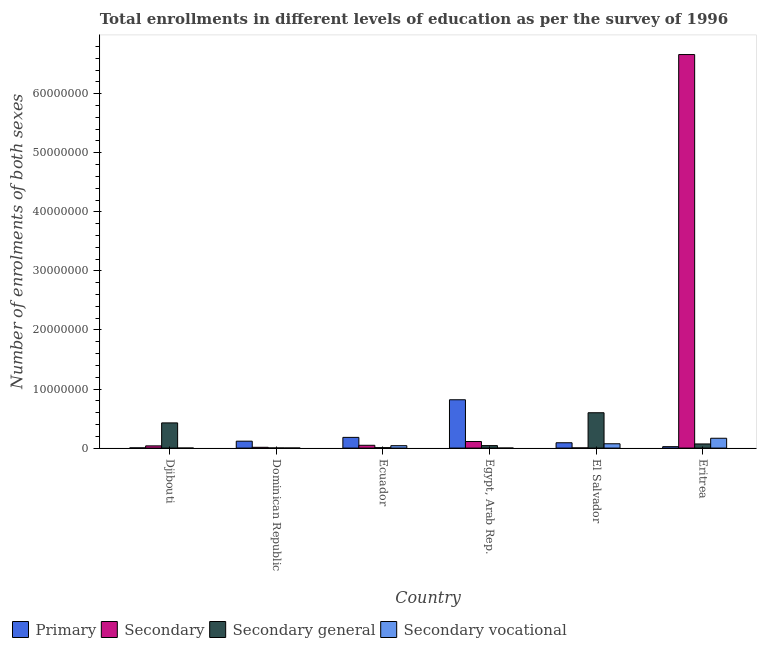How many different coloured bars are there?
Give a very brief answer. 4. Are the number of bars per tick equal to the number of legend labels?
Provide a short and direct response. Yes. How many bars are there on the 4th tick from the left?
Provide a short and direct response. 4. How many bars are there on the 6th tick from the right?
Provide a short and direct response. 4. What is the label of the 5th group of bars from the left?
Your answer should be compact. El Salvador. In how many cases, is the number of bars for a given country not equal to the number of legend labels?
Provide a succinct answer. 0. What is the number of enrolments in secondary education in Eritrea?
Your response must be concise. 6.66e+07. Across all countries, what is the maximum number of enrolments in secondary vocational education?
Offer a terse response. 1.67e+06. Across all countries, what is the minimum number of enrolments in secondary vocational education?
Ensure brevity in your answer.  4600. In which country was the number of enrolments in secondary general education maximum?
Your response must be concise. El Salvador. In which country was the number of enrolments in primary education minimum?
Provide a short and direct response. Djibouti. What is the total number of enrolments in secondary education in the graph?
Provide a short and direct response. 6.88e+07. What is the difference between the number of enrolments in secondary general education in Ecuador and that in El Salvador?
Ensure brevity in your answer.  -5.91e+06. What is the difference between the number of enrolments in secondary vocational education in Djibouti and the number of enrolments in primary education in Egypt, Arab Rep.?
Offer a very short reply. -8.18e+06. What is the average number of enrolments in secondary general education per country?
Ensure brevity in your answer.  1.91e+06. What is the difference between the number of enrolments in secondary vocational education and number of enrolments in primary education in Dominican Republic?
Your response must be concise. -1.16e+06. What is the ratio of the number of enrolments in secondary general education in Ecuador to that in Eritrea?
Keep it short and to the point. 0.1. Is the difference between the number of enrolments in secondary education in El Salvador and Eritrea greater than the difference between the number of enrolments in secondary vocational education in El Salvador and Eritrea?
Offer a terse response. No. What is the difference between the highest and the second highest number of enrolments in secondary education?
Ensure brevity in your answer.  6.55e+07. What is the difference between the highest and the lowest number of enrolments in secondary vocational education?
Provide a succinct answer. 1.66e+06. Is the sum of the number of enrolments in secondary vocational education in Ecuador and Egypt, Arab Rep. greater than the maximum number of enrolments in secondary education across all countries?
Offer a very short reply. No. What does the 2nd bar from the left in Egypt, Arab Rep. represents?
Offer a very short reply. Secondary. What does the 4th bar from the right in Egypt, Arab Rep. represents?
Offer a terse response. Primary. How many countries are there in the graph?
Offer a terse response. 6. What is the difference between two consecutive major ticks on the Y-axis?
Your answer should be compact. 1.00e+07. Are the values on the major ticks of Y-axis written in scientific E-notation?
Make the answer very short. No. Does the graph contain grids?
Your answer should be compact. No. How many legend labels are there?
Offer a very short reply. 4. What is the title of the graph?
Provide a succinct answer. Total enrollments in different levels of education as per the survey of 1996. What is the label or title of the Y-axis?
Ensure brevity in your answer.  Number of enrolments of both sexes. What is the Number of enrolments of both sexes in Primary in Djibouti?
Make the answer very short. 3.62e+04. What is the Number of enrolments of both sexes of Secondary in Djibouti?
Your answer should be compact. 3.76e+05. What is the Number of enrolments of both sexes in Secondary general in Djibouti?
Keep it short and to the point. 4.26e+06. What is the Number of enrolments of both sexes in Secondary vocational in Djibouti?
Offer a terse response. 4600. What is the Number of enrolments of both sexes of Primary in Dominican Republic?
Provide a succinct answer. 1.17e+06. What is the Number of enrolments of both sexes of Secondary in Dominican Republic?
Make the answer very short. 1.33e+05. What is the Number of enrolments of both sexes in Secondary general in Dominican Republic?
Ensure brevity in your answer.  2.15e+04. What is the Number of enrolments of both sexes in Secondary vocational in Dominican Republic?
Your answer should be very brief. 1.40e+04. What is the Number of enrolments of both sexes in Primary in Ecuador?
Make the answer very short. 1.81e+06. What is the Number of enrolments of both sexes of Secondary in Ecuador?
Make the answer very short. 4.74e+05. What is the Number of enrolments of both sexes in Secondary general in Ecuador?
Your answer should be very brief. 7.29e+04. What is the Number of enrolments of both sexes in Secondary vocational in Ecuador?
Give a very brief answer. 4.10e+05. What is the Number of enrolments of both sexes in Primary in Egypt, Arab Rep.?
Your answer should be compact. 8.19e+06. What is the Number of enrolments of both sexes of Secondary in Egypt, Arab Rep.?
Give a very brief answer. 1.11e+06. What is the Number of enrolments of both sexes in Secondary general in Egypt, Arab Rep.?
Give a very brief answer. 4.22e+05. What is the Number of enrolments of both sexes in Secondary vocational in Egypt, Arab Rep.?
Keep it short and to the point. 6059. What is the Number of enrolments of both sexes of Primary in El Salvador?
Give a very brief answer. 9.03e+05. What is the Number of enrolments of both sexes in Secondary in El Salvador?
Make the answer very short. 3.05e+04. What is the Number of enrolments of both sexes of Secondary general in El Salvador?
Provide a short and direct response. 5.99e+06. What is the Number of enrolments of both sexes in Secondary vocational in El Salvador?
Offer a very short reply. 7.31e+05. What is the Number of enrolments of both sexes of Primary in Eritrea?
Make the answer very short. 2.42e+05. What is the Number of enrolments of both sexes in Secondary in Eritrea?
Offer a terse response. 6.66e+07. What is the Number of enrolments of both sexes of Secondary general in Eritrea?
Keep it short and to the point. 7.01e+05. What is the Number of enrolments of both sexes in Secondary vocational in Eritrea?
Make the answer very short. 1.67e+06. Across all countries, what is the maximum Number of enrolments of both sexes in Primary?
Keep it short and to the point. 8.19e+06. Across all countries, what is the maximum Number of enrolments of both sexes in Secondary?
Offer a very short reply. 6.66e+07. Across all countries, what is the maximum Number of enrolments of both sexes in Secondary general?
Give a very brief answer. 5.99e+06. Across all countries, what is the maximum Number of enrolments of both sexes in Secondary vocational?
Offer a terse response. 1.67e+06. Across all countries, what is the minimum Number of enrolments of both sexes in Primary?
Offer a terse response. 3.62e+04. Across all countries, what is the minimum Number of enrolments of both sexes in Secondary?
Your answer should be very brief. 3.05e+04. Across all countries, what is the minimum Number of enrolments of both sexes in Secondary general?
Your response must be concise. 2.15e+04. Across all countries, what is the minimum Number of enrolments of both sexes of Secondary vocational?
Give a very brief answer. 4600. What is the total Number of enrolments of both sexes of Primary in the graph?
Provide a succinct answer. 1.23e+07. What is the total Number of enrolments of both sexes of Secondary in the graph?
Provide a short and direct response. 6.88e+07. What is the total Number of enrolments of both sexes in Secondary general in the graph?
Your answer should be very brief. 1.15e+07. What is the total Number of enrolments of both sexes in Secondary vocational in the graph?
Your answer should be compact. 2.83e+06. What is the difference between the Number of enrolments of both sexes of Primary in Djibouti and that in Dominican Republic?
Offer a very short reply. -1.14e+06. What is the difference between the Number of enrolments of both sexes of Secondary in Djibouti and that in Dominican Republic?
Provide a succinct answer. 2.43e+05. What is the difference between the Number of enrolments of both sexes of Secondary general in Djibouti and that in Dominican Republic?
Your response must be concise. 4.24e+06. What is the difference between the Number of enrolments of both sexes of Secondary vocational in Djibouti and that in Dominican Republic?
Provide a succinct answer. -9372. What is the difference between the Number of enrolments of both sexes in Primary in Djibouti and that in Ecuador?
Keep it short and to the point. -1.78e+06. What is the difference between the Number of enrolments of both sexes in Secondary in Djibouti and that in Ecuador?
Offer a very short reply. -9.83e+04. What is the difference between the Number of enrolments of both sexes in Secondary general in Djibouti and that in Ecuador?
Offer a terse response. 4.19e+06. What is the difference between the Number of enrolments of both sexes of Secondary vocational in Djibouti and that in Ecuador?
Your response must be concise. -4.05e+05. What is the difference between the Number of enrolments of both sexes in Primary in Djibouti and that in Egypt, Arab Rep.?
Keep it short and to the point. -8.15e+06. What is the difference between the Number of enrolments of both sexes in Secondary in Djibouti and that in Egypt, Arab Rep.?
Keep it short and to the point. -7.37e+05. What is the difference between the Number of enrolments of both sexes of Secondary general in Djibouti and that in Egypt, Arab Rep.?
Offer a terse response. 3.84e+06. What is the difference between the Number of enrolments of both sexes in Secondary vocational in Djibouti and that in Egypt, Arab Rep.?
Your answer should be compact. -1459. What is the difference between the Number of enrolments of both sexes in Primary in Djibouti and that in El Salvador?
Your answer should be compact. -8.66e+05. What is the difference between the Number of enrolments of both sexes of Secondary in Djibouti and that in El Salvador?
Your answer should be very brief. 3.45e+05. What is the difference between the Number of enrolments of both sexes in Secondary general in Djibouti and that in El Salvador?
Ensure brevity in your answer.  -1.72e+06. What is the difference between the Number of enrolments of both sexes in Secondary vocational in Djibouti and that in El Salvador?
Ensure brevity in your answer.  -7.26e+05. What is the difference between the Number of enrolments of both sexes of Primary in Djibouti and that in Eritrea?
Keep it short and to the point. -2.06e+05. What is the difference between the Number of enrolments of both sexes of Secondary in Djibouti and that in Eritrea?
Provide a short and direct response. -6.63e+07. What is the difference between the Number of enrolments of both sexes in Secondary general in Djibouti and that in Eritrea?
Ensure brevity in your answer.  3.56e+06. What is the difference between the Number of enrolments of both sexes of Secondary vocational in Djibouti and that in Eritrea?
Give a very brief answer. -1.66e+06. What is the difference between the Number of enrolments of both sexes in Primary in Dominican Republic and that in Ecuador?
Offer a terse response. -6.41e+05. What is the difference between the Number of enrolments of both sexes in Secondary in Dominican Republic and that in Ecuador?
Give a very brief answer. -3.41e+05. What is the difference between the Number of enrolments of both sexes of Secondary general in Dominican Republic and that in Ecuador?
Keep it short and to the point. -5.14e+04. What is the difference between the Number of enrolments of both sexes of Secondary vocational in Dominican Republic and that in Ecuador?
Give a very brief answer. -3.96e+05. What is the difference between the Number of enrolments of both sexes in Primary in Dominican Republic and that in Egypt, Arab Rep.?
Provide a succinct answer. -7.01e+06. What is the difference between the Number of enrolments of both sexes of Secondary in Dominican Republic and that in Egypt, Arab Rep.?
Your answer should be compact. -9.79e+05. What is the difference between the Number of enrolments of both sexes in Secondary general in Dominican Republic and that in Egypt, Arab Rep.?
Provide a succinct answer. -4.01e+05. What is the difference between the Number of enrolments of both sexes in Secondary vocational in Dominican Republic and that in Egypt, Arab Rep.?
Your answer should be compact. 7913. What is the difference between the Number of enrolments of both sexes of Primary in Dominican Republic and that in El Salvador?
Provide a succinct answer. 2.69e+05. What is the difference between the Number of enrolments of both sexes of Secondary in Dominican Republic and that in El Salvador?
Offer a terse response. 1.02e+05. What is the difference between the Number of enrolments of both sexes in Secondary general in Dominican Republic and that in El Salvador?
Your answer should be compact. -5.96e+06. What is the difference between the Number of enrolments of both sexes in Secondary vocational in Dominican Republic and that in El Salvador?
Your answer should be compact. -7.17e+05. What is the difference between the Number of enrolments of both sexes of Primary in Dominican Republic and that in Eritrea?
Ensure brevity in your answer.  9.30e+05. What is the difference between the Number of enrolments of both sexes of Secondary in Dominican Republic and that in Eritrea?
Offer a terse response. -6.65e+07. What is the difference between the Number of enrolments of both sexes in Secondary general in Dominican Republic and that in Eritrea?
Offer a terse response. -6.80e+05. What is the difference between the Number of enrolments of both sexes of Secondary vocational in Dominican Republic and that in Eritrea?
Offer a very short reply. -1.65e+06. What is the difference between the Number of enrolments of both sexes of Primary in Ecuador and that in Egypt, Arab Rep.?
Give a very brief answer. -6.37e+06. What is the difference between the Number of enrolments of both sexes in Secondary in Ecuador and that in Egypt, Arab Rep.?
Your answer should be very brief. -6.38e+05. What is the difference between the Number of enrolments of both sexes of Secondary general in Ecuador and that in Egypt, Arab Rep.?
Make the answer very short. -3.49e+05. What is the difference between the Number of enrolments of both sexes of Secondary vocational in Ecuador and that in Egypt, Arab Rep.?
Ensure brevity in your answer.  4.03e+05. What is the difference between the Number of enrolments of both sexes of Primary in Ecuador and that in El Salvador?
Offer a terse response. 9.10e+05. What is the difference between the Number of enrolments of both sexes in Secondary in Ecuador and that in El Salvador?
Provide a short and direct response. 4.43e+05. What is the difference between the Number of enrolments of both sexes of Secondary general in Ecuador and that in El Salvador?
Offer a very short reply. -5.91e+06. What is the difference between the Number of enrolments of both sexes of Secondary vocational in Ecuador and that in El Salvador?
Provide a succinct answer. -3.22e+05. What is the difference between the Number of enrolments of both sexes of Primary in Ecuador and that in Eritrea?
Provide a short and direct response. 1.57e+06. What is the difference between the Number of enrolments of both sexes in Secondary in Ecuador and that in Eritrea?
Provide a short and direct response. -6.62e+07. What is the difference between the Number of enrolments of both sexes in Secondary general in Ecuador and that in Eritrea?
Provide a succinct answer. -6.28e+05. What is the difference between the Number of enrolments of both sexes in Secondary vocational in Ecuador and that in Eritrea?
Offer a very short reply. -1.26e+06. What is the difference between the Number of enrolments of both sexes of Primary in Egypt, Arab Rep. and that in El Salvador?
Make the answer very short. 7.28e+06. What is the difference between the Number of enrolments of both sexes of Secondary in Egypt, Arab Rep. and that in El Salvador?
Offer a terse response. 1.08e+06. What is the difference between the Number of enrolments of both sexes of Secondary general in Egypt, Arab Rep. and that in El Salvador?
Provide a succinct answer. -5.56e+06. What is the difference between the Number of enrolments of both sexes in Secondary vocational in Egypt, Arab Rep. and that in El Salvador?
Offer a very short reply. -7.25e+05. What is the difference between the Number of enrolments of both sexes in Primary in Egypt, Arab Rep. and that in Eritrea?
Make the answer very short. 7.94e+06. What is the difference between the Number of enrolments of both sexes in Secondary in Egypt, Arab Rep. and that in Eritrea?
Offer a terse response. -6.55e+07. What is the difference between the Number of enrolments of both sexes of Secondary general in Egypt, Arab Rep. and that in Eritrea?
Ensure brevity in your answer.  -2.79e+05. What is the difference between the Number of enrolments of both sexes in Secondary vocational in Egypt, Arab Rep. and that in Eritrea?
Offer a very short reply. -1.66e+06. What is the difference between the Number of enrolments of both sexes in Primary in El Salvador and that in Eritrea?
Keep it short and to the point. 6.61e+05. What is the difference between the Number of enrolments of both sexes in Secondary in El Salvador and that in Eritrea?
Your response must be concise. -6.66e+07. What is the difference between the Number of enrolments of both sexes of Secondary general in El Salvador and that in Eritrea?
Your answer should be very brief. 5.28e+06. What is the difference between the Number of enrolments of both sexes of Secondary vocational in El Salvador and that in Eritrea?
Provide a short and direct response. -9.34e+05. What is the difference between the Number of enrolments of both sexes of Primary in Djibouti and the Number of enrolments of both sexes of Secondary in Dominican Republic?
Your answer should be very brief. -9.65e+04. What is the difference between the Number of enrolments of both sexes of Primary in Djibouti and the Number of enrolments of both sexes of Secondary general in Dominican Republic?
Your answer should be very brief. 1.47e+04. What is the difference between the Number of enrolments of both sexes of Primary in Djibouti and the Number of enrolments of both sexes of Secondary vocational in Dominican Republic?
Your response must be concise. 2.23e+04. What is the difference between the Number of enrolments of both sexes in Secondary in Djibouti and the Number of enrolments of both sexes in Secondary general in Dominican Republic?
Give a very brief answer. 3.54e+05. What is the difference between the Number of enrolments of both sexes of Secondary in Djibouti and the Number of enrolments of both sexes of Secondary vocational in Dominican Republic?
Your response must be concise. 3.62e+05. What is the difference between the Number of enrolments of both sexes of Secondary general in Djibouti and the Number of enrolments of both sexes of Secondary vocational in Dominican Republic?
Offer a very short reply. 4.25e+06. What is the difference between the Number of enrolments of both sexes of Primary in Djibouti and the Number of enrolments of both sexes of Secondary in Ecuador?
Your response must be concise. -4.38e+05. What is the difference between the Number of enrolments of both sexes in Primary in Djibouti and the Number of enrolments of both sexes in Secondary general in Ecuador?
Your answer should be very brief. -3.67e+04. What is the difference between the Number of enrolments of both sexes of Primary in Djibouti and the Number of enrolments of both sexes of Secondary vocational in Ecuador?
Provide a short and direct response. -3.73e+05. What is the difference between the Number of enrolments of both sexes in Secondary in Djibouti and the Number of enrolments of both sexes in Secondary general in Ecuador?
Ensure brevity in your answer.  3.03e+05. What is the difference between the Number of enrolments of both sexes in Secondary in Djibouti and the Number of enrolments of both sexes in Secondary vocational in Ecuador?
Keep it short and to the point. -3.40e+04. What is the difference between the Number of enrolments of both sexes in Secondary general in Djibouti and the Number of enrolments of both sexes in Secondary vocational in Ecuador?
Make the answer very short. 3.85e+06. What is the difference between the Number of enrolments of both sexes in Primary in Djibouti and the Number of enrolments of both sexes in Secondary in Egypt, Arab Rep.?
Provide a short and direct response. -1.08e+06. What is the difference between the Number of enrolments of both sexes of Primary in Djibouti and the Number of enrolments of both sexes of Secondary general in Egypt, Arab Rep.?
Your answer should be compact. -3.86e+05. What is the difference between the Number of enrolments of both sexes in Primary in Djibouti and the Number of enrolments of both sexes in Secondary vocational in Egypt, Arab Rep.?
Your answer should be compact. 3.02e+04. What is the difference between the Number of enrolments of both sexes in Secondary in Djibouti and the Number of enrolments of both sexes in Secondary general in Egypt, Arab Rep.?
Your answer should be compact. -4.69e+04. What is the difference between the Number of enrolments of both sexes in Secondary in Djibouti and the Number of enrolments of both sexes in Secondary vocational in Egypt, Arab Rep.?
Provide a succinct answer. 3.69e+05. What is the difference between the Number of enrolments of both sexes of Secondary general in Djibouti and the Number of enrolments of both sexes of Secondary vocational in Egypt, Arab Rep.?
Give a very brief answer. 4.26e+06. What is the difference between the Number of enrolments of both sexes of Primary in Djibouti and the Number of enrolments of both sexes of Secondary in El Salvador?
Provide a succinct answer. 5760. What is the difference between the Number of enrolments of both sexes of Primary in Djibouti and the Number of enrolments of both sexes of Secondary general in El Salvador?
Ensure brevity in your answer.  -5.95e+06. What is the difference between the Number of enrolments of both sexes of Primary in Djibouti and the Number of enrolments of both sexes of Secondary vocational in El Salvador?
Ensure brevity in your answer.  -6.95e+05. What is the difference between the Number of enrolments of both sexes of Secondary in Djibouti and the Number of enrolments of both sexes of Secondary general in El Salvador?
Your response must be concise. -5.61e+06. What is the difference between the Number of enrolments of both sexes of Secondary in Djibouti and the Number of enrolments of both sexes of Secondary vocational in El Salvador?
Offer a terse response. -3.55e+05. What is the difference between the Number of enrolments of both sexes in Secondary general in Djibouti and the Number of enrolments of both sexes in Secondary vocational in El Salvador?
Keep it short and to the point. 3.53e+06. What is the difference between the Number of enrolments of both sexes of Primary in Djibouti and the Number of enrolments of both sexes of Secondary in Eritrea?
Keep it short and to the point. -6.66e+07. What is the difference between the Number of enrolments of both sexes in Primary in Djibouti and the Number of enrolments of both sexes in Secondary general in Eritrea?
Offer a terse response. -6.65e+05. What is the difference between the Number of enrolments of both sexes of Primary in Djibouti and the Number of enrolments of both sexes of Secondary vocational in Eritrea?
Give a very brief answer. -1.63e+06. What is the difference between the Number of enrolments of both sexes in Secondary in Djibouti and the Number of enrolments of both sexes in Secondary general in Eritrea?
Offer a terse response. -3.26e+05. What is the difference between the Number of enrolments of both sexes of Secondary in Djibouti and the Number of enrolments of both sexes of Secondary vocational in Eritrea?
Provide a succinct answer. -1.29e+06. What is the difference between the Number of enrolments of both sexes in Secondary general in Djibouti and the Number of enrolments of both sexes in Secondary vocational in Eritrea?
Make the answer very short. 2.60e+06. What is the difference between the Number of enrolments of both sexes in Primary in Dominican Republic and the Number of enrolments of both sexes in Secondary in Ecuador?
Your response must be concise. 6.98e+05. What is the difference between the Number of enrolments of both sexes in Primary in Dominican Republic and the Number of enrolments of both sexes in Secondary general in Ecuador?
Give a very brief answer. 1.10e+06. What is the difference between the Number of enrolments of both sexes of Primary in Dominican Republic and the Number of enrolments of both sexes of Secondary vocational in Ecuador?
Provide a succinct answer. 7.62e+05. What is the difference between the Number of enrolments of both sexes of Secondary in Dominican Republic and the Number of enrolments of both sexes of Secondary general in Ecuador?
Keep it short and to the point. 5.98e+04. What is the difference between the Number of enrolments of both sexes in Secondary in Dominican Republic and the Number of enrolments of both sexes in Secondary vocational in Ecuador?
Make the answer very short. -2.77e+05. What is the difference between the Number of enrolments of both sexes of Secondary general in Dominican Republic and the Number of enrolments of both sexes of Secondary vocational in Ecuador?
Your answer should be very brief. -3.88e+05. What is the difference between the Number of enrolments of both sexes of Primary in Dominican Republic and the Number of enrolments of both sexes of Secondary in Egypt, Arab Rep.?
Keep it short and to the point. 5.94e+04. What is the difference between the Number of enrolments of both sexes in Primary in Dominican Republic and the Number of enrolments of both sexes in Secondary general in Egypt, Arab Rep.?
Give a very brief answer. 7.49e+05. What is the difference between the Number of enrolments of both sexes in Primary in Dominican Republic and the Number of enrolments of both sexes in Secondary vocational in Egypt, Arab Rep.?
Provide a short and direct response. 1.17e+06. What is the difference between the Number of enrolments of both sexes in Secondary in Dominican Republic and the Number of enrolments of both sexes in Secondary general in Egypt, Arab Rep.?
Your answer should be compact. -2.90e+05. What is the difference between the Number of enrolments of both sexes of Secondary in Dominican Republic and the Number of enrolments of both sexes of Secondary vocational in Egypt, Arab Rep.?
Your answer should be compact. 1.27e+05. What is the difference between the Number of enrolments of both sexes of Secondary general in Dominican Republic and the Number of enrolments of both sexes of Secondary vocational in Egypt, Arab Rep.?
Your answer should be compact. 1.54e+04. What is the difference between the Number of enrolments of both sexes in Primary in Dominican Republic and the Number of enrolments of both sexes in Secondary in El Salvador?
Your response must be concise. 1.14e+06. What is the difference between the Number of enrolments of both sexes in Primary in Dominican Republic and the Number of enrolments of both sexes in Secondary general in El Salvador?
Ensure brevity in your answer.  -4.81e+06. What is the difference between the Number of enrolments of both sexes in Primary in Dominican Republic and the Number of enrolments of both sexes in Secondary vocational in El Salvador?
Offer a terse response. 4.41e+05. What is the difference between the Number of enrolments of both sexes of Secondary in Dominican Republic and the Number of enrolments of both sexes of Secondary general in El Salvador?
Your answer should be very brief. -5.85e+06. What is the difference between the Number of enrolments of both sexes of Secondary in Dominican Republic and the Number of enrolments of both sexes of Secondary vocational in El Salvador?
Your answer should be very brief. -5.98e+05. What is the difference between the Number of enrolments of both sexes in Secondary general in Dominican Republic and the Number of enrolments of both sexes in Secondary vocational in El Salvador?
Your response must be concise. -7.10e+05. What is the difference between the Number of enrolments of both sexes in Primary in Dominican Republic and the Number of enrolments of both sexes in Secondary in Eritrea?
Keep it short and to the point. -6.55e+07. What is the difference between the Number of enrolments of both sexes of Primary in Dominican Republic and the Number of enrolments of both sexes of Secondary general in Eritrea?
Offer a very short reply. 4.70e+05. What is the difference between the Number of enrolments of both sexes in Primary in Dominican Republic and the Number of enrolments of both sexes in Secondary vocational in Eritrea?
Offer a very short reply. -4.94e+05. What is the difference between the Number of enrolments of both sexes in Secondary in Dominican Republic and the Number of enrolments of both sexes in Secondary general in Eritrea?
Your answer should be compact. -5.69e+05. What is the difference between the Number of enrolments of both sexes of Secondary in Dominican Republic and the Number of enrolments of both sexes of Secondary vocational in Eritrea?
Ensure brevity in your answer.  -1.53e+06. What is the difference between the Number of enrolments of both sexes of Secondary general in Dominican Republic and the Number of enrolments of both sexes of Secondary vocational in Eritrea?
Keep it short and to the point. -1.64e+06. What is the difference between the Number of enrolments of both sexes of Primary in Ecuador and the Number of enrolments of both sexes of Secondary in Egypt, Arab Rep.?
Offer a terse response. 7.00e+05. What is the difference between the Number of enrolments of both sexes of Primary in Ecuador and the Number of enrolments of both sexes of Secondary general in Egypt, Arab Rep.?
Give a very brief answer. 1.39e+06. What is the difference between the Number of enrolments of both sexes in Primary in Ecuador and the Number of enrolments of both sexes in Secondary vocational in Egypt, Arab Rep.?
Your response must be concise. 1.81e+06. What is the difference between the Number of enrolments of both sexes in Secondary in Ecuador and the Number of enrolments of both sexes in Secondary general in Egypt, Arab Rep.?
Your answer should be compact. 5.14e+04. What is the difference between the Number of enrolments of both sexes of Secondary in Ecuador and the Number of enrolments of both sexes of Secondary vocational in Egypt, Arab Rep.?
Your answer should be compact. 4.68e+05. What is the difference between the Number of enrolments of both sexes of Secondary general in Ecuador and the Number of enrolments of both sexes of Secondary vocational in Egypt, Arab Rep.?
Give a very brief answer. 6.68e+04. What is the difference between the Number of enrolments of both sexes in Primary in Ecuador and the Number of enrolments of both sexes in Secondary in El Salvador?
Your answer should be compact. 1.78e+06. What is the difference between the Number of enrolments of both sexes of Primary in Ecuador and the Number of enrolments of both sexes of Secondary general in El Salvador?
Provide a succinct answer. -4.17e+06. What is the difference between the Number of enrolments of both sexes of Primary in Ecuador and the Number of enrolments of both sexes of Secondary vocational in El Salvador?
Your answer should be very brief. 1.08e+06. What is the difference between the Number of enrolments of both sexes in Secondary in Ecuador and the Number of enrolments of both sexes in Secondary general in El Salvador?
Give a very brief answer. -5.51e+06. What is the difference between the Number of enrolments of both sexes in Secondary in Ecuador and the Number of enrolments of both sexes in Secondary vocational in El Salvador?
Offer a very short reply. -2.57e+05. What is the difference between the Number of enrolments of both sexes of Secondary general in Ecuador and the Number of enrolments of both sexes of Secondary vocational in El Salvador?
Your answer should be compact. -6.58e+05. What is the difference between the Number of enrolments of both sexes of Primary in Ecuador and the Number of enrolments of both sexes of Secondary in Eritrea?
Make the answer very short. -6.48e+07. What is the difference between the Number of enrolments of both sexes of Primary in Ecuador and the Number of enrolments of both sexes of Secondary general in Eritrea?
Your answer should be compact. 1.11e+06. What is the difference between the Number of enrolments of both sexes of Primary in Ecuador and the Number of enrolments of both sexes of Secondary vocational in Eritrea?
Give a very brief answer. 1.47e+05. What is the difference between the Number of enrolments of both sexes in Secondary in Ecuador and the Number of enrolments of both sexes in Secondary general in Eritrea?
Your answer should be compact. -2.27e+05. What is the difference between the Number of enrolments of both sexes of Secondary in Ecuador and the Number of enrolments of both sexes of Secondary vocational in Eritrea?
Ensure brevity in your answer.  -1.19e+06. What is the difference between the Number of enrolments of both sexes in Secondary general in Ecuador and the Number of enrolments of both sexes in Secondary vocational in Eritrea?
Ensure brevity in your answer.  -1.59e+06. What is the difference between the Number of enrolments of both sexes of Primary in Egypt, Arab Rep. and the Number of enrolments of both sexes of Secondary in El Salvador?
Provide a succinct answer. 8.15e+06. What is the difference between the Number of enrolments of both sexes in Primary in Egypt, Arab Rep. and the Number of enrolments of both sexes in Secondary general in El Salvador?
Your response must be concise. 2.20e+06. What is the difference between the Number of enrolments of both sexes in Primary in Egypt, Arab Rep. and the Number of enrolments of both sexes in Secondary vocational in El Salvador?
Make the answer very short. 7.45e+06. What is the difference between the Number of enrolments of both sexes of Secondary in Egypt, Arab Rep. and the Number of enrolments of both sexes of Secondary general in El Salvador?
Provide a succinct answer. -4.87e+06. What is the difference between the Number of enrolments of both sexes in Secondary in Egypt, Arab Rep. and the Number of enrolments of both sexes in Secondary vocational in El Salvador?
Keep it short and to the point. 3.81e+05. What is the difference between the Number of enrolments of both sexes in Secondary general in Egypt, Arab Rep. and the Number of enrolments of both sexes in Secondary vocational in El Salvador?
Your answer should be compact. -3.09e+05. What is the difference between the Number of enrolments of both sexes of Primary in Egypt, Arab Rep. and the Number of enrolments of both sexes of Secondary in Eritrea?
Offer a terse response. -5.84e+07. What is the difference between the Number of enrolments of both sexes of Primary in Egypt, Arab Rep. and the Number of enrolments of both sexes of Secondary general in Eritrea?
Give a very brief answer. 7.48e+06. What is the difference between the Number of enrolments of both sexes of Primary in Egypt, Arab Rep. and the Number of enrolments of both sexes of Secondary vocational in Eritrea?
Your response must be concise. 6.52e+06. What is the difference between the Number of enrolments of both sexes of Secondary in Egypt, Arab Rep. and the Number of enrolments of both sexes of Secondary general in Eritrea?
Provide a short and direct response. 4.11e+05. What is the difference between the Number of enrolments of both sexes in Secondary in Egypt, Arab Rep. and the Number of enrolments of both sexes in Secondary vocational in Eritrea?
Offer a very short reply. -5.53e+05. What is the difference between the Number of enrolments of both sexes in Secondary general in Egypt, Arab Rep. and the Number of enrolments of both sexes in Secondary vocational in Eritrea?
Provide a short and direct response. -1.24e+06. What is the difference between the Number of enrolments of both sexes in Primary in El Salvador and the Number of enrolments of both sexes in Secondary in Eritrea?
Keep it short and to the point. -6.57e+07. What is the difference between the Number of enrolments of both sexes of Primary in El Salvador and the Number of enrolments of both sexes of Secondary general in Eritrea?
Offer a very short reply. 2.01e+05. What is the difference between the Number of enrolments of both sexes of Primary in El Salvador and the Number of enrolments of both sexes of Secondary vocational in Eritrea?
Make the answer very short. -7.63e+05. What is the difference between the Number of enrolments of both sexes in Secondary in El Salvador and the Number of enrolments of both sexes in Secondary general in Eritrea?
Offer a terse response. -6.71e+05. What is the difference between the Number of enrolments of both sexes in Secondary in El Salvador and the Number of enrolments of both sexes in Secondary vocational in Eritrea?
Make the answer very short. -1.63e+06. What is the difference between the Number of enrolments of both sexes in Secondary general in El Salvador and the Number of enrolments of both sexes in Secondary vocational in Eritrea?
Your response must be concise. 4.32e+06. What is the average Number of enrolments of both sexes in Primary per country?
Provide a short and direct response. 2.06e+06. What is the average Number of enrolments of both sexes of Secondary per country?
Your response must be concise. 1.15e+07. What is the average Number of enrolments of both sexes of Secondary general per country?
Give a very brief answer. 1.91e+06. What is the average Number of enrolments of both sexes of Secondary vocational per country?
Keep it short and to the point. 4.72e+05. What is the difference between the Number of enrolments of both sexes in Primary and Number of enrolments of both sexes in Secondary in Djibouti?
Your response must be concise. -3.39e+05. What is the difference between the Number of enrolments of both sexes in Primary and Number of enrolments of both sexes in Secondary general in Djibouti?
Make the answer very short. -4.23e+06. What is the difference between the Number of enrolments of both sexes in Primary and Number of enrolments of both sexes in Secondary vocational in Djibouti?
Provide a short and direct response. 3.16e+04. What is the difference between the Number of enrolments of both sexes of Secondary and Number of enrolments of both sexes of Secondary general in Djibouti?
Ensure brevity in your answer.  -3.89e+06. What is the difference between the Number of enrolments of both sexes of Secondary and Number of enrolments of both sexes of Secondary vocational in Djibouti?
Make the answer very short. 3.71e+05. What is the difference between the Number of enrolments of both sexes of Secondary general and Number of enrolments of both sexes of Secondary vocational in Djibouti?
Offer a terse response. 4.26e+06. What is the difference between the Number of enrolments of both sexes of Primary and Number of enrolments of both sexes of Secondary in Dominican Republic?
Offer a very short reply. 1.04e+06. What is the difference between the Number of enrolments of both sexes in Primary and Number of enrolments of both sexes in Secondary general in Dominican Republic?
Ensure brevity in your answer.  1.15e+06. What is the difference between the Number of enrolments of both sexes in Primary and Number of enrolments of both sexes in Secondary vocational in Dominican Republic?
Your answer should be very brief. 1.16e+06. What is the difference between the Number of enrolments of both sexes of Secondary and Number of enrolments of both sexes of Secondary general in Dominican Republic?
Offer a very short reply. 1.11e+05. What is the difference between the Number of enrolments of both sexes in Secondary and Number of enrolments of both sexes in Secondary vocational in Dominican Republic?
Give a very brief answer. 1.19e+05. What is the difference between the Number of enrolments of both sexes of Secondary general and Number of enrolments of both sexes of Secondary vocational in Dominican Republic?
Make the answer very short. 7528. What is the difference between the Number of enrolments of both sexes of Primary and Number of enrolments of both sexes of Secondary in Ecuador?
Offer a very short reply. 1.34e+06. What is the difference between the Number of enrolments of both sexes of Primary and Number of enrolments of both sexes of Secondary general in Ecuador?
Provide a succinct answer. 1.74e+06. What is the difference between the Number of enrolments of both sexes in Primary and Number of enrolments of both sexes in Secondary vocational in Ecuador?
Offer a terse response. 1.40e+06. What is the difference between the Number of enrolments of both sexes of Secondary and Number of enrolments of both sexes of Secondary general in Ecuador?
Make the answer very short. 4.01e+05. What is the difference between the Number of enrolments of both sexes of Secondary and Number of enrolments of both sexes of Secondary vocational in Ecuador?
Provide a succinct answer. 6.43e+04. What is the difference between the Number of enrolments of both sexes in Secondary general and Number of enrolments of both sexes in Secondary vocational in Ecuador?
Ensure brevity in your answer.  -3.37e+05. What is the difference between the Number of enrolments of both sexes of Primary and Number of enrolments of both sexes of Secondary in Egypt, Arab Rep.?
Your response must be concise. 7.07e+06. What is the difference between the Number of enrolments of both sexes of Primary and Number of enrolments of both sexes of Secondary general in Egypt, Arab Rep.?
Offer a terse response. 7.76e+06. What is the difference between the Number of enrolments of both sexes in Primary and Number of enrolments of both sexes in Secondary vocational in Egypt, Arab Rep.?
Provide a succinct answer. 8.18e+06. What is the difference between the Number of enrolments of both sexes in Secondary and Number of enrolments of both sexes in Secondary general in Egypt, Arab Rep.?
Your response must be concise. 6.90e+05. What is the difference between the Number of enrolments of both sexes in Secondary and Number of enrolments of both sexes in Secondary vocational in Egypt, Arab Rep.?
Your answer should be compact. 1.11e+06. What is the difference between the Number of enrolments of both sexes in Secondary general and Number of enrolments of both sexes in Secondary vocational in Egypt, Arab Rep.?
Give a very brief answer. 4.16e+05. What is the difference between the Number of enrolments of both sexes of Primary and Number of enrolments of both sexes of Secondary in El Salvador?
Ensure brevity in your answer.  8.72e+05. What is the difference between the Number of enrolments of both sexes in Primary and Number of enrolments of both sexes in Secondary general in El Salvador?
Offer a terse response. -5.08e+06. What is the difference between the Number of enrolments of both sexes in Primary and Number of enrolments of both sexes in Secondary vocational in El Salvador?
Offer a very short reply. 1.72e+05. What is the difference between the Number of enrolments of both sexes of Secondary and Number of enrolments of both sexes of Secondary general in El Salvador?
Provide a succinct answer. -5.96e+06. What is the difference between the Number of enrolments of both sexes of Secondary and Number of enrolments of both sexes of Secondary vocational in El Salvador?
Provide a short and direct response. -7.01e+05. What is the difference between the Number of enrolments of both sexes in Secondary general and Number of enrolments of both sexes in Secondary vocational in El Salvador?
Your answer should be very brief. 5.26e+06. What is the difference between the Number of enrolments of both sexes of Primary and Number of enrolments of both sexes of Secondary in Eritrea?
Ensure brevity in your answer.  -6.64e+07. What is the difference between the Number of enrolments of both sexes in Primary and Number of enrolments of both sexes in Secondary general in Eritrea?
Offer a terse response. -4.60e+05. What is the difference between the Number of enrolments of both sexes in Primary and Number of enrolments of both sexes in Secondary vocational in Eritrea?
Provide a short and direct response. -1.42e+06. What is the difference between the Number of enrolments of both sexes in Secondary and Number of enrolments of both sexes in Secondary general in Eritrea?
Ensure brevity in your answer.  6.59e+07. What is the difference between the Number of enrolments of both sexes of Secondary and Number of enrolments of both sexes of Secondary vocational in Eritrea?
Your response must be concise. 6.50e+07. What is the difference between the Number of enrolments of both sexes of Secondary general and Number of enrolments of both sexes of Secondary vocational in Eritrea?
Provide a succinct answer. -9.64e+05. What is the ratio of the Number of enrolments of both sexes of Primary in Djibouti to that in Dominican Republic?
Provide a short and direct response. 0.03. What is the ratio of the Number of enrolments of both sexes of Secondary in Djibouti to that in Dominican Republic?
Provide a succinct answer. 2.83. What is the ratio of the Number of enrolments of both sexes of Secondary general in Djibouti to that in Dominican Republic?
Make the answer very short. 198.34. What is the ratio of the Number of enrolments of both sexes in Secondary vocational in Djibouti to that in Dominican Republic?
Offer a very short reply. 0.33. What is the ratio of the Number of enrolments of both sexes of Primary in Djibouti to that in Ecuador?
Keep it short and to the point. 0.02. What is the ratio of the Number of enrolments of both sexes in Secondary in Djibouti to that in Ecuador?
Offer a very short reply. 0.79. What is the ratio of the Number of enrolments of both sexes in Secondary general in Djibouti to that in Ecuador?
Your answer should be very brief. 58.51. What is the ratio of the Number of enrolments of both sexes in Secondary vocational in Djibouti to that in Ecuador?
Offer a terse response. 0.01. What is the ratio of the Number of enrolments of both sexes of Primary in Djibouti to that in Egypt, Arab Rep.?
Your answer should be compact. 0. What is the ratio of the Number of enrolments of both sexes of Secondary in Djibouti to that in Egypt, Arab Rep.?
Offer a terse response. 0.34. What is the ratio of the Number of enrolments of both sexes in Secondary general in Djibouti to that in Egypt, Arab Rep.?
Provide a short and direct response. 10.1. What is the ratio of the Number of enrolments of both sexes in Secondary vocational in Djibouti to that in Egypt, Arab Rep.?
Your answer should be very brief. 0.76. What is the ratio of the Number of enrolments of both sexes of Primary in Djibouti to that in El Salvador?
Offer a very short reply. 0.04. What is the ratio of the Number of enrolments of both sexes of Secondary in Djibouti to that in El Salvador?
Keep it short and to the point. 12.33. What is the ratio of the Number of enrolments of both sexes of Secondary general in Djibouti to that in El Salvador?
Make the answer very short. 0.71. What is the ratio of the Number of enrolments of both sexes in Secondary vocational in Djibouti to that in El Salvador?
Provide a succinct answer. 0.01. What is the ratio of the Number of enrolments of both sexes of Primary in Djibouti to that in Eritrea?
Offer a terse response. 0.15. What is the ratio of the Number of enrolments of both sexes in Secondary in Djibouti to that in Eritrea?
Keep it short and to the point. 0.01. What is the ratio of the Number of enrolments of both sexes in Secondary general in Djibouti to that in Eritrea?
Provide a succinct answer. 6.08. What is the ratio of the Number of enrolments of both sexes of Secondary vocational in Djibouti to that in Eritrea?
Give a very brief answer. 0. What is the ratio of the Number of enrolments of both sexes of Primary in Dominican Republic to that in Ecuador?
Keep it short and to the point. 0.65. What is the ratio of the Number of enrolments of both sexes of Secondary in Dominican Republic to that in Ecuador?
Your response must be concise. 0.28. What is the ratio of the Number of enrolments of both sexes in Secondary general in Dominican Republic to that in Ecuador?
Give a very brief answer. 0.29. What is the ratio of the Number of enrolments of both sexes of Secondary vocational in Dominican Republic to that in Ecuador?
Your answer should be compact. 0.03. What is the ratio of the Number of enrolments of both sexes in Primary in Dominican Republic to that in Egypt, Arab Rep.?
Give a very brief answer. 0.14. What is the ratio of the Number of enrolments of both sexes in Secondary in Dominican Republic to that in Egypt, Arab Rep.?
Provide a succinct answer. 0.12. What is the ratio of the Number of enrolments of both sexes of Secondary general in Dominican Republic to that in Egypt, Arab Rep.?
Your response must be concise. 0.05. What is the ratio of the Number of enrolments of both sexes of Secondary vocational in Dominican Republic to that in Egypt, Arab Rep.?
Your answer should be compact. 2.31. What is the ratio of the Number of enrolments of both sexes of Primary in Dominican Republic to that in El Salvador?
Make the answer very short. 1.3. What is the ratio of the Number of enrolments of both sexes in Secondary in Dominican Republic to that in El Salvador?
Your answer should be compact. 4.36. What is the ratio of the Number of enrolments of both sexes in Secondary general in Dominican Republic to that in El Salvador?
Give a very brief answer. 0. What is the ratio of the Number of enrolments of both sexes of Secondary vocational in Dominican Republic to that in El Salvador?
Provide a short and direct response. 0.02. What is the ratio of the Number of enrolments of both sexes of Primary in Dominican Republic to that in Eritrea?
Provide a short and direct response. 4.85. What is the ratio of the Number of enrolments of both sexes in Secondary in Dominican Republic to that in Eritrea?
Ensure brevity in your answer.  0. What is the ratio of the Number of enrolments of both sexes of Secondary general in Dominican Republic to that in Eritrea?
Keep it short and to the point. 0.03. What is the ratio of the Number of enrolments of both sexes in Secondary vocational in Dominican Republic to that in Eritrea?
Ensure brevity in your answer.  0.01. What is the ratio of the Number of enrolments of both sexes of Primary in Ecuador to that in Egypt, Arab Rep.?
Your response must be concise. 0.22. What is the ratio of the Number of enrolments of both sexes in Secondary in Ecuador to that in Egypt, Arab Rep.?
Offer a very short reply. 0.43. What is the ratio of the Number of enrolments of both sexes in Secondary general in Ecuador to that in Egypt, Arab Rep.?
Offer a very short reply. 0.17. What is the ratio of the Number of enrolments of both sexes of Secondary vocational in Ecuador to that in Egypt, Arab Rep.?
Provide a succinct answer. 67.59. What is the ratio of the Number of enrolments of both sexes of Primary in Ecuador to that in El Salvador?
Your answer should be compact. 2.01. What is the ratio of the Number of enrolments of both sexes in Secondary in Ecuador to that in El Salvador?
Give a very brief answer. 15.55. What is the ratio of the Number of enrolments of both sexes of Secondary general in Ecuador to that in El Salvador?
Offer a terse response. 0.01. What is the ratio of the Number of enrolments of both sexes in Secondary vocational in Ecuador to that in El Salvador?
Keep it short and to the point. 0.56. What is the ratio of the Number of enrolments of both sexes in Primary in Ecuador to that in Eritrea?
Offer a very short reply. 7.5. What is the ratio of the Number of enrolments of both sexes in Secondary in Ecuador to that in Eritrea?
Keep it short and to the point. 0.01. What is the ratio of the Number of enrolments of both sexes of Secondary general in Ecuador to that in Eritrea?
Ensure brevity in your answer.  0.1. What is the ratio of the Number of enrolments of both sexes in Secondary vocational in Ecuador to that in Eritrea?
Give a very brief answer. 0.25. What is the ratio of the Number of enrolments of both sexes in Primary in Egypt, Arab Rep. to that in El Salvador?
Your answer should be compact. 9.07. What is the ratio of the Number of enrolments of both sexes in Secondary in Egypt, Arab Rep. to that in El Salvador?
Your answer should be compact. 36.51. What is the ratio of the Number of enrolments of both sexes in Secondary general in Egypt, Arab Rep. to that in El Salvador?
Your answer should be compact. 0.07. What is the ratio of the Number of enrolments of both sexes of Secondary vocational in Egypt, Arab Rep. to that in El Salvador?
Offer a very short reply. 0.01. What is the ratio of the Number of enrolments of both sexes of Primary in Egypt, Arab Rep. to that in Eritrea?
Offer a terse response. 33.86. What is the ratio of the Number of enrolments of both sexes of Secondary in Egypt, Arab Rep. to that in Eritrea?
Give a very brief answer. 0.02. What is the ratio of the Number of enrolments of both sexes of Secondary general in Egypt, Arab Rep. to that in Eritrea?
Keep it short and to the point. 0.6. What is the ratio of the Number of enrolments of both sexes in Secondary vocational in Egypt, Arab Rep. to that in Eritrea?
Offer a very short reply. 0. What is the ratio of the Number of enrolments of both sexes of Primary in El Salvador to that in Eritrea?
Ensure brevity in your answer.  3.73. What is the ratio of the Number of enrolments of both sexes of Secondary general in El Salvador to that in Eritrea?
Your answer should be very brief. 8.54. What is the ratio of the Number of enrolments of both sexes of Secondary vocational in El Salvador to that in Eritrea?
Keep it short and to the point. 0.44. What is the difference between the highest and the second highest Number of enrolments of both sexes of Primary?
Offer a terse response. 6.37e+06. What is the difference between the highest and the second highest Number of enrolments of both sexes in Secondary?
Offer a very short reply. 6.55e+07. What is the difference between the highest and the second highest Number of enrolments of both sexes in Secondary general?
Your answer should be compact. 1.72e+06. What is the difference between the highest and the second highest Number of enrolments of both sexes of Secondary vocational?
Give a very brief answer. 9.34e+05. What is the difference between the highest and the lowest Number of enrolments of both sexes of Primary?
Provide a short and direct response. 8.15e+06. What is the difference between the highest and the lowest Number of enrolments of both sexes in Secondary?
Your answer should be very brief. 6.66e+07. What is the difference between the highest and the lowest Number of enrolments of both sexes of Secondary general?
Your answer should be very brief. 5.96e+06. What is the difference between the highest and the lowest Number of enrolments of both sexes in Secondary vocational?
Keep it short and to the point. 1.66e+06. 